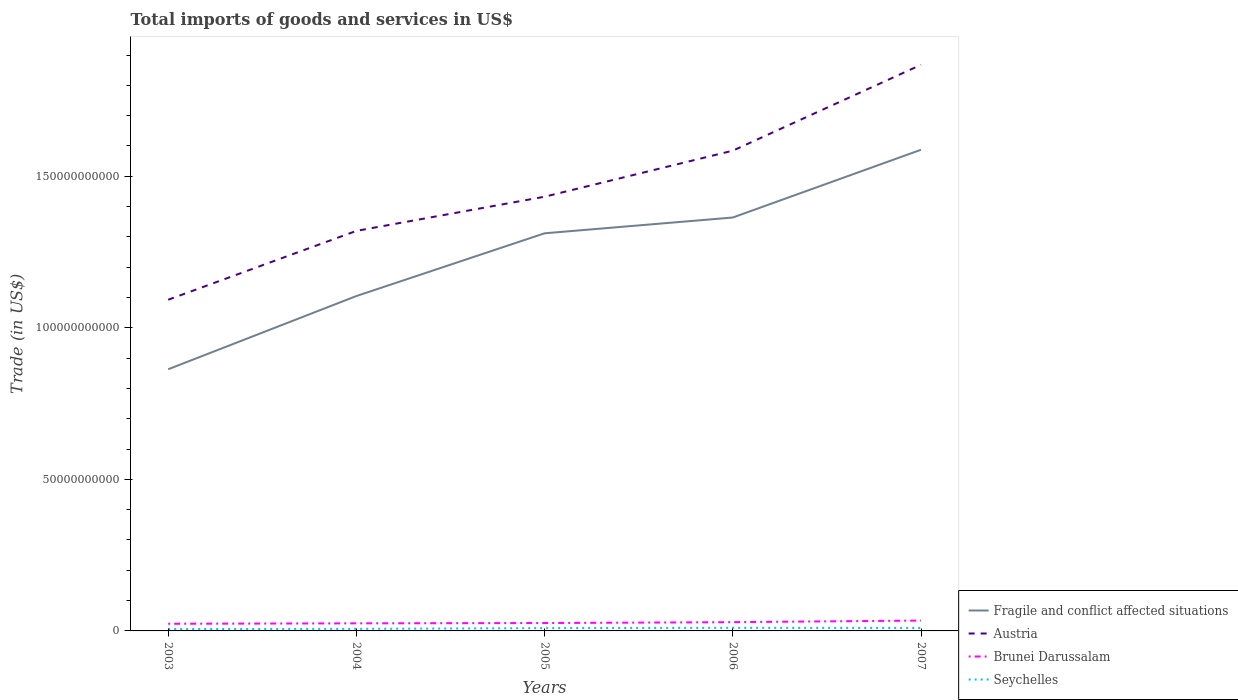How many different coloured lines are there?
Your response must be concise. 4. Does the line corresponding to Brunei Darussalam intersect with the line corresponding to Austria?
Make the answer very short. No. Is the number of lines equal to the number of legend labels?
Offer a very short reply. Yes. Across all years, what is the maximum total imports of goods and services in Brunei Darussalam?
Make the answer very short. 2.36e+09. In which year was the total imports of goods and services in Austria maximum?
Your answer should be very brief. 2003. What is the total total imports of goods and services in Brunei Darussalam in the graph?
Your response must be concise. -9.14e+08. What is the difference between the highest and the second highest total imports of goods and services in Fragile and conflict affected situations?
Offer a very short reply. 7.24e+1. Is the total imports of goods and services in Fragile and conflict affected situations strictly greater than the total imports of goods and services in Brunei Darussalam over the years?
Your answer should be very brief. No. What is the difference between two consecutive major ticks on the Y-axis?
Provide a succinct answer. 5.00e+1. Are the values on the major ticks of Y-axis written in scientific E-notation?
Your response must be concise. No. Does the graph contain grids?
Your answer should be very brief. No. How many legend labels are there?
Offer a terse response. 4. How are the legend labels stacked?
Provide a succinct answer. Vertical. What is the title of the graph?
Offer a very short reply. Total imports of goods and services in US$. Does "Kenya" appear as one of the legend labels in the graph?
Your answer should be very brief. No. What is the label or title of the X-axis?
Your answer should be compact. Years. What is the label or title of the Y-axis?
Your response must be concise. Trade (in US$). What is the Trade (in US$) in Fragile and conflict affected situations in 2003?
Your answer should be very brief. 8.63e+1. What is the Trade (in US$) of Austria in 2003?
Provide a succinct answer. 1.09e+11. What is the Trade (in US$) in Brunei Darussalam in 2003?
Make the answer very short. 2.36e+09. What is the Trade (in US$) in Seychelles in 2003?
Offer a very short reply. 6.11e+08. What is the Trade (in US$) in Fragile and conflict affected situations in 2004?
Your response must be concise. 1.10e+11. What is the Trade (in US$) of Austria in 2004?
Give a very brief answer. 1.32e+11. What is the Trade (in US$) in Brunei Darussalam in 2004?
Keep it short and to the point. 2.50e+09. What is the Trade (in US$) in Seychelles in 2004?
Your answer should be compact. 6.85e+08. What is the Trade (in US$) of Fragile and conflict affected situations in 2005?
Provide a short and direct response. 1.31e+11. What is the Trade (in US$) in Austria in 2005?
Provide a succinct answer. 1.43e+11. What is the Trade (in US$) in Brunei Darussalam in 2005?
Ensure brevity in your answer.  2.60e+09. What is the Trade (in US$) in Seychelles in 2005?
Ensure brevity in your answer.  9.19e+08. What is the Trade (in US$) in Fragile and conflict affected situations in 2006?
Provide a short and direct response. 1.36e+11. What is the Trade (in US$) of Austria in 2006?
Provide a succinct answer. 1.58e+11. What is the Trade (in US$) of Brunei Darussalam in 2006?
Your response must be concise. 2.89e+09. What is the Trade (in US$) of Seychelles in 2006?
Your response must be concise. 1.02e+09. What is the Trade (in US$) of Fragile and conflict affected situations in 2007?
Ensure brevity in your answer.  1.59e+11. What is the Trade (in US$) in Austria in 2007?
Offer a very short reply. 1.87e+11. What is the Trade (in US$) in Brunei Darussalam in 2007?
Provide a succinct answer. 3.42e+09. What is the Trade (in US$) in Seychelles in 2007?
Your answer should be compact. 9.49e+08. Across all years, what is the maximum Trade (in US$) of Fragile and conflict affected situations?
Ensure brevity in your answer.  1.59e+11. Across all years, what is the maximum Trade (in US$) in Austria?
Offer a terse response. 1.87e+11. Across all years, what is the maximum Trade (in US$) in Brunei Darussalam?
Give a very brief answer. 3.42e+09. Across all years, what is the maximum Trade (in US$) in Seychelles?
Provide a succinct answer. 1.02e+09. Across all years, what is the minimum Trade (in US$) in Fragile and conflict affected situations?
Your answer should be very brief. 8.63e+1. Across all years, what is the minimum Trade (in US$) in Austria?
Ensure brevity in your answer.  1.09e+11. Across all years, what is the minimum Trade (in US$) in Brunei Darussalam?
Your answer should be very brief. 2.36e+09. Across all years, what is the minimum Trade (in US$) of Seychelles?
Your answer should be very brief. 6.11e+08. What is the total Trade (in US$) of Fragile and conflict affected situations in the graph?
Provide a succinct answer. 6.23e+11. What is the total Trade (in US$) in Austria in the graph?
Make the answer very short. 7.30e+11. What is the total Trade (in US$) of Brunei Darussalam in the graph?
Your answer should be very brief. 1.38e+1. What is the total Trade (in US$) of Seychelles in the graph?
Your answer should be very brief. 4.19e+09. What is the difference between the Trade (in US$) of Fragile and conflict affected situations in 2003 and that in 2004?
Provide a succinct answer. -2.42e+1. What is the difference between the Trade (in US$) of Austria in 2003 and that in 2004?
Your response must be concise. -2.27e+1. What is the difference between the Trade (in US$) of Brunei Darussalam in 2003 and that in 2004?
Provide a short and direct response. -1.44e+08. What is the difference between the Trade (in US$) in Seychelles in 2003 and that in 2004?
Provide a short and direct response. -7.40e+07. What is the difference between the Trade (in US$) of Fragile and conflict affected situations in 2003 and that in 2005?
Provide a succinct answer. -4.49e+1. What is the difference between the Trade (in US$) in Austria in 2003 and that in 2005?
Ensure brevity in your answer.  -3.40e+1. What is the difference between the Trade (in US$) in Brunei Darussalam in 2003 and that in 2005?
Your response must be concise. -2.42e+08. What is the difference between the Trade (in US$) of Seychelles in 2003 and that in 2005?
Ensure brevity in your answer.  -3.09e+08. What is the difference between the Trade (in US$) of Fragile and conflict affected situations in 2003 and that in 2006?
Your answer should be very brief. -5.01e+1. What is the difference between the Trade (in US$) of Austria in 2003 and that in 2006?
Keep it short and to the point. -4.92e+1. What is the difference between the Trade (in US$) in Brunei Darussalam in 2003 and that in 2006?
Make the answer very short. -5.34e+08. What is the difference between the Trade (in US$) in Seychelles in 2003 and that in 2006?
Your answer should be very brief. -4.11e+08. What is the difference between the Trade (in US$) in Fragile and conflict affected situations in 2003 and that in 2007?
Your response must be concise. -7.24e+1. What is the difference between the Trade (in US$) in Austria in 2003 and that in 2007?
Keep it short and to the point. -7.75e+1. What is the difference between the Trade (in US$) in Brunei Darussalam in 2003 and that in 2007?
Offer a terse response. -1.06e+09. What is the difference between the Trade (in US$) of Seychelles in 2003 and that in 2007?
Give a very brief answer. -3.38e+08. What is the difference between the Trade (in US$) of Fragile and conflict affected situations in 2004 and that in 2005?
Your answer should be very brief. -2.07e+1. What is the difference between the Trade (in US$) in Austria in 2004 and that in 2005?
Ensure brevity in your answer.  -1.13e+1. What is the difference between the Trade (in US$) in Brunei Darussalam in 2004 and that in 2005?
Keep it short and to the point. -9.84e+07. What is the difference between the Trade (in US$) in Seychelles in 2004 and that in 2005?
Provide a succinct answer. -2.35e+08. What is the difference between the Trade (in US$) of Fragile and conflict affected situations in 2004 and that in 2006?
Provide a succinct answer. -2.59e+1. What is the difference between the Trade (in US$) of Austria in 2004 and that in 2006?
Offer a very short reply. -2.65e+1. What is the difference between the Trade (in US$) of Brunei Darussalam in 2004 and that in 2006?
Your answer should be very brief. -3.90e+08. What is the difference between the Trade (in US$) of Seychelles in 2004 and that in 2006?
Provide a succinct answer. -3.37e+08. What is the difference between the Trade (in US$) of Fragile and conflict affected situations in 2004 and that in 2007?
Give a very brief answer. -4.83e+1. What is the difference between the Trade (in US$) in Austria in 2004 and that in 2007?
Keep it short and to the point. -5.48e+1. What is the difference between the Trade (in US$) of Brunei Darussalam in 2004 and that in 2007?
Your answer should be compact. -9.14e+08. What is the difference between the Trade (in US$) of Seychelles in 2004 and that in 2007?
Offer a very short reply. -2.64e+08. What is the difference between the Trade (in US$) of Fragile and conflict affected situations in 2005 and that in 2006?
Keep it short and to the point. -5.21e+09. What is the difference between the Trade (in US$) of Austria in 2005 and that in 2006?
Provide a short and direct response. -1.52e+1. What is the difference between the Trade (in US$) of Brunei Darussalam in 2005 and that in 2006?
Offer a very short reply. -2.91e+08. What is the difference between the Trade (in US$) of Seychelles in 2005 and that in 2006?
Offer a very short reply. -1.03e+08. What is the difference between the Trade (in US$) in Fragile and conflict affected situations in 2005 and that in 2007?
Your answer should be compact. -2.76e+1. What is the difference between the Trade (in US$) of Austria in 2005 and that in 2007?
Ensure brevity in your answer.  -4.35e+1. What is the difference between the Trade (in US$) of Brunei Darussalam in 2005 and that in 2007?
Your answer should be compact. -8.16e+08. What is the difference between the Trade (in US$) of Seychelles in 2005 and that in 2007?
Give a very brief answer. -2.98e+07. What is the difference between the Trade (in US$) of Fragile and conflict affected situations in 2006 and that in 2007?
Offer a terse response. -2.24e+1. What is the difference between the Trade (in US$) in Austria in 2006 and that in 2007?
Offer a terse response. -2.83e+1. What is the difference between the Trade (in US$) in Brunei Darussalam in 2006 and that in 2007?
Make the answer very short. -5.24e+08. What is the difference between the Trade (in US$) of Seychelles in 2006 and that in 2007?
Make the answer very short. 7.29e+07. What is the difference between the Trade (in US$) of Fragile and conflict affected situations in 2003 and the Trade (in US$) of Austria in 2004?
Keep it short and to the point. -4.57e+1. What is the difference between the Trade (in US$) of Fragile and conflict affected situations in 2003 and the Trade (in US$) of Brunei Darussalam in 2004?
Keep it short and to the point. 8.38e+1. What is the difference between the Trade (in US$) of Fragile and conflict affected situations in 2003 and the Trade (in US$) of Seychelles in 2004?
Your answer should be compact. 8.57e+1. What is the difference between the Trade (in US$) of Austria in 2003 and the Trade (in US$) of Brunei Darussalam in 2004?
Provide a succinct answer. 1.07e+11. What is the difference between the Trade (in US$) in Austria in 2003 and the Trade (in US$) in Seychelles in 2004?
Offer a very short reply. 1.09e+11. What is the difference between the Trade (in US$) of Brunei Darussalam in 2003 and the Trade (in US$) of Seychelles in 2004?
Offer a very short reply. 1.67e+09. What is the difference between the Trade (in US$) of Fragile and conflict affected situations in 2003 and the Trade (in US$) of Austria in 2005?
Your answer should be very brief. -5.69e+1. What is the difference between the Trade (in US$) of Fragile and conflict affected situations in 2003 and the Trade (in US$) of Brunei Darussalam in 2005?
Ensure brevity in your answer.  8.37e+1. What is the difference between the Trade (in US$) of Fragile and conflict affected situations in 2003 and the Trade (in US$) of Seychelles in 2005?
Keep it short and to the point. 8.54e+1. What is the difference between the Trade (in US$) in Austria in 2003 and the Trade (in US$) in Brunei Darussalam in 2005?
Offer a very short reply. 1.07e+11. What is the difference between the Trade (in US$) of Austria in 2003 and the Trade (in US$) of Seychelles in 2005?
Provide a short and direct response. 1.08e+11. What is the difference between the Trade (in US$) in Brunei Darussalam in 2003 and the Trade (in US$) in Seychelles in 2005?
Provide a succinct answer. 1.44e+09. What is the difference between the Trade (in US$) of Fragile and conflict affected situations in 2003 and the Trade (in US$) of Austria in 2006?
Your response must be concise. -7.21e+1. What is the difference between the Trade (in US$) of Fragile and conflict affected situations in 2003 and the Trade (in US$) of Brunei Darussalam in 2006?
Your answer should be very brief. 8.34e+1. What is the difference between the Trade (in US$) of Fragile and conflict affected situations in 2003 and the Trade (in US$) of Seychelles in 2006?
Offer a terse response. 8.53e+1. What is the difference between the Trade (in US$) of Austria in 2003 and the Trade (in US$) of Brunei Darussalam in 2006?
Your answer should be compact. 1.06e+11. What is the difference between the Trade (in US$) of Austria in 2003 and the Trade (in US$) of Seychelles in 2006?
Give a very brief answer. 1.08e+11. What is the difference between the Trade (in US$) in Brunei Darussalam in 2003 and the Trade (in US$) in Seychelles in 2006?
Offer a terse response. 1.34e+09. What is the difference between the Trade (in US$) in Fragile and conflict affected situations in 2003 and the Trade (in US$) in Austria in 2007?
Your answer should be very brief. -1.00e+11. What is the difference between the Trade (in US$) in Fragile and conflict affected situations in 2003 and the Trade (in US$) in Brunei Darussalam in 2007?
Your answer should be compact. 8.29e+1. What is the difference between the Trade (in US$) of Fragile and conflict affected situations in 2003 and the Trade (in US$) of Seychelles in 2007?
Your response must be concise. 8.54e+1. What is the difference between the Trade (in US$) of Austria in 2003 and the Trade (in US$) of Brunei Darussalam in 2007?
Ensure brevity in your answer.  1.06e+11. What is the difference between the Trade (in US$) in Austria in 2003 and the Trade (in US$) in Seychelles in 2007?
Your answer should be compact. 1.08e+11. What is the difference between the Trade (in US$) in Brunei Darussalam in 2003 and the Trade (in US$) in Seychelles in 2007?
Your response must be concise. 1.41e+09. What is the difference between the Trade (in US$) in Fragile and conflict affected situations in 2004 and the Trade (in US$) in Austria in 2005?
Keep it short and to the point. -3.28e+1. What is the difference between the Trade (in US$) of Fragile and conflict affected situations in 2004 and the Trade (in US$) of Brunei Darussalam in 2005?
Your response must be concise. 1.08e+11. What is the difference between the Trade (in US$) of Fragile and conflict affected situations in 2004 and the Trade (in US$) of Seychelles in 2005?
Provide a short and direct response. 1.10e+11. What is the difference between the Trade (in US$) in Austria in 2004 and the Trade (in US$) in Brunei Darussalam in 2005?
Give a very brief answer. 1.29e+11. What is the difference between the Trade (in US$) of Austria in 2004 and the Trade (in US$) of Seychelles in 2005?
Offer a terse response. 1.31e+11. What is the difference between the Trade (in US$) of Brunei Darussalam in 2004 and the Trade (in US$) of Seychelles in 2005?
Your answer should be compact. 1.58e+09. What is the difference between the Trade (in US$) of Fragile and conflict affected situations in 2004 and the Trade (in US$) of Austria in 2006?
Give a very brief answer. -4.80e+1. What is the difference between the Trade (in US$) in Fragile and conflict affected situations in 2004 and the Trade (in US$) in Brunei Darussalam in 2006?
Offer a very short reply. 1.08e+11. What is the difference between the Trade (in US$) in Fragile and conflict affected situations in 2004 and the Trade (in US$) in Seychelles in 2006?
Give a very brief answer. 1.09e+11. What is the difference between the Trade (in US$) of Austria in 2004 and the Trade (in US$) of Brunei Darussalam in 2006?
Your answer should be very brief. 1.29e+11. What is the difference between the Trade (in US$) in Austria in 2004 and the Trade (in US$) in Seychelles in 2006?
Your answer should be compact. 1.31e+11. What is the difference between the Trade (in US$) in Brunei Darussalam in 2004 and the Trade (in US$) in Seychelles in 2006?
Your response must be concise. 1.48e+09. What is the difference between the Trade (in US$) in Fragile and conflict affected situations in 2004 and the Trade (in US$) in Austria in 2007?
Offer a very short reply. -7.63e+1. What is the difference between the Trade (in US$) of Fragile and conflict affected situations in 2004 and the Trade (in US$) of Brunei Darussalam in 2007?
Give a very brief answer. 1.07e+11. What is the difference between the Trade (in US$) of Fragile and conflict affected situations in 2004 and the Trade (in US$) of Seychelles in 2007?
Offer a terse response. 1.10e+11. What is the difference between the Trade (in US$) of Austria in 2004 and the Trade (in US$) of Brunei Darussalam in 2007?
Your response must be concise. 1.29e+11. What is the difference between the Trade (in US$) in Austria in 2004 and the Trade (in US$) in Seychelles in 2007?
Provide a succinct answer. 1.31e+11. What is the difference between the Trade (in US$) in Brunei Darussalam in 2004 and the Trade (in US$) in Seychelles in 2007?
Your response must be concise. 1.55e+09. What is the difference between the Trade (in US$) of Fragile and conflict affected situations in 2005 and the Trade (in US$) of Austria in 2006?
Keep it short and to the point. -2.73e+1. What is the difference between the Trade (in US$) of Fragile and conflict affected situations in 2005 and the Trade (in US$) of Brunei Darussalam in 2006?
Offer a terse response. 1.28e+11. What is the difference between the Trade (in US$) in Fragile and conflict affected situations in 2005 and the Trade (in US$) in Seychelles in 2006?
Provide a succinct answer. 1.30e+11. What is the difference between the Trade (in US$) in Austria in 2005 and the Trade (in US$) in Brunei Darussalam in 2006?
Your response must be concise. 1.40e+11. What is the difference between the Trade (in US$) of Austria in 2005 and the Trade (in US$) of Seychelles in 2006?
Your answer should be very brief. 1.42e+11. What is the difference between the Trade (in US$) of Brunei Darussalam in 2005 and the Trade (in US$) of Seychelles in 2006?
Your answer should be very brief. 1.58e+09. What is the difference between the Trade (in US$) in Fragile and conflict affected situations in 2005 and the Trade (in US$) in Austria in 2007?
Ensure brevity in your answer.  -5.56e+1. What is the difference between the Trade (in US$) of Fragile and conflict affected situations in 2005 and the Trade (in US$) of Brunei Darussalam in 2007?
Your answer should be compact. 1.28e+11. What is the difference between the Trade (in US$) of Fragile and conflict affected situations in 2005 and the Trade (in US$) of Seychelles in 2007?
Your answer should be compact. 1.30e+11. What is the difference between the Trade (in US$) of Austria in 2005 and the Trade (in US$) of Brunei Darussalam in 2007?
Provide a succinct answer. 1.40e+11. What is the difference between the Trade (in US$) in Austria in 2005 and the Trade (in US$) in Seychelles in 2007?
Your response must be concise. 1.42e+11. What is the difference between the Trade (in US$) in Brunei Darussalam in 2005 and the Trade (in US$) in Seychelles in 2007?
Offer a very short reply. 1.65e+09. What is the difference between the Trade (in US$) in Fragile and conflict affected situations in 2006 and the Trade (in US$) in Austria in 2007?
Your answer should be compact. -5.04e+1. What is the difference between the Trade (in US$) of Fragile and conflict affected situations in 2006 and the Trade (in US$) of Brunei Darussalam in 2007?
Offer a very short reply. 1.33e+11. What is the difference between the Trade (in US$) in Fragile and conflict affected situations in 2006 and the Trade (in US$) in Seychelles in 2007?
Make the answer very short. 1.35e+11. What is the difference between the Trade (in US$) in Austria in 2006 and the Trade (in US$) in Brunei Darussalam in 2007?
Keep it short and to the point. 1.55e+11. What is the difference between the Trade (in US$) of Austria in 2006 and the Trade (in US$) of Seychelles in 2007?
Provide a succinct answer. 1.58e+11. What is the difference between the Trade (in US$) of Brunei Darussalam in 2006 and the Trade (in US$) of Seychelles in 2007?
Offer a very short reply. 1.94e+09. What is the average Trade (in US$) in Fragile and conflict affected situations per year?
Make the answer very short. 1.25e+11. What is the average Trade (in US$) of Austria per year?
Offer a terse response. 1.46e+11. What is the average Trade (in US$) in Brunei Darussalam per year?
Make the answer very short. 2.75e+09. What is the average Trade (in US$) in Seychelles per year?
Make the answer very short. 8.37e+08. In the year 2003, what is the difference between the Trade (in US$) of Fragile and conflict affected situations and Trade (in US$) of Austria?
Your response must be concise. -2.29e+1. In the year 2003, what is the difference between the Trade (in US$) of Fragile and conflict affected situations and Trade (in US$) of Brunei Darussalam?
Your answer should be compact. 8.40e+1. In the year 2003, what is the difference between the Trade (in US$) in Fragile and conflict affected situations and Trade (in US$) in Seychelles?
Ensure brevity in your answer.  8.57e+1. In the year 2003, what is the difference between the Trade (in US$) in Austria and Trade (in US$) in Brunei Darussalam?
Your answer should be compact. 1.07e+11. In the year 2003, what is the difference between the Trade (in US$) in Austria and Trade (in US$) in Seychelles?
Your response must be concise. 1.09e+11. In the year 2003, what is the difference between the Trade (in US$) of Brunei Darussalam and Trade (in US$) of Seychelles?
Provide a short and direct response. 1.75e+09. In the year 2004, what is the difference between the Trade (in US$) in Fragile and conflict affected situations and Trade (in US$) in Austria?
Offer a terse response. -2.15e+1. In the year 2004, what is the difference between the Trade (in US$) of Fragile and conflict affected situations and Trade (in US$) of Brunei Darussalam?
Offer a terse response. 1.08e+11. In the year 2004, what is the difference between the Trade (in US$) in Fragile and conflict affected situations and Trade (in US$) in Seychelles?
Provide a short and direct response. 1.10e+11. In the year 2004, what is the difference between the Trade (in US$) of Austria and Trade (in US$) of Brunei Darussalam?
Provide a succinct answer. 1.29e+11. In the year 2004, what is the difference between the Trade (in US$) in Austria and Trade (in US$) in Seychelles?
Your response must be concise. 1.31e+11. In the year 2004, what is the difference between the Trade (in US$) in Brunei Darussalam and Trade (in US$) in Seychelles?
Ensure brevity in your answer.  1.82e+09. In the year 2005, what is the difference between the Trade (in US$) in Fragile and conflict affected situations and Trade (in US$) in Austria?
Make the answer very short. -1.21e+1. In the year 2005, what is the difference between the Trade (in US$) of Fragile and conflict affected situations and Trade (in US$) of Brunei Darussalam?
Keep it short and to the point. 1.29e+11. In the year 2005, what is the difference between the Trade (in US$) of Fragile and conflict affected situations and Trade (in US$) of Seychelles?
Offer a terse response. 1.30e+11. In the year 2005, what is the difference between the Trade (in US$) of Austria and Trade (in US$) of Brunei Darussalam?
Your answer should be compact. 1.41e+11. In the year 2005, what is the difference between the Trade (in US$) in Austria and Trade (in US$) in Seychelles?
Keep it short and to the point. 1.42e+11. In the year 2005, what is the difference between the Trade (in US$) in Brunei Darussalam and Trade (in US$) in Seychelles?
Give a very brief answer. 1.68e+09. In the year 2006, what is the difference between the Trade (in US$) in Fragile and conflict affected situations and Trade (in US$) in Austria?
Offer a very short reply. -2.21e+1. In the year 2006, what is the difference between the Trade (in US$) of Fragile and conflict affected situations and Trade (in US$) of Brunei Darussalam?
Provide a succinct answer. 1.34e+11. In the year 2006, what is the difference between the Trade (in US$) in Fragile and conflict affected situations and Trade (in US$) in Seychelles?
Ensure brevity in your answer.  1.35e+11. In the year 2006, what is the difference between the Trade (in US$) of Austria and Trade (in US$) of Brunei Darussalam?
Your answer should be compact. 1.56e+11. In the year 2006, what is the difference between the Trade (in US$) in Austria and Trade (in US$) in Seychelles?
Keep it short and to the point. 1.57e+11. In the year 2006, what is the difference between the Trade (in US$) in Brunei Darussalam and Trade (in US$) in Seychelles?
Your response must be concise. 1.87e+09. In the year 2007, what is the difference between the Trade (in US$) in Fragile and conflict affected situations and Trade (in US$) in Austria?
Provide a succinct answer. -2.80e+1. In the year 2007, what is the difference between the Trade (in US$) in Fragile and conflict affected situations and Trade (in US$) in Brunei Darussalam?
Provide a short and direct response. 1.55e+11. In the year 2007, what is the difference between the Trade (in US$) of Fragile and conflict affected situations and Trade (in US$) of Seychelles?
Make the answer very short. 1.58e+11. In the year 2007, what is the difference between the Trade (in US$) in Austria and Trade (in US$) in Brunei Darussalam?
Offer a terse response. 1.83e+11. In the year 2007, what is the difference between the Trade (in US$) of Austria and Trade (in US$) of Seychelles?
Offer a very short reply. 1.86e+11. In the year 2007, what is the difference between the Trade (in US$) of Brunei Darussalam and Trade (in US$) of Seychelles?
Your answer should be very brief. 2.47e+09. What is the ratio of the Trade (in US$) in Fragile and conflict affected situations in 2003 to that in 2004?
Provide a succinct answer. 0.78. What is the ratio of the Trade (in US$) of Austria in 2003 to that in 2004?
Offer a very short reply. 0.83. What is the ratio of the Trade (in US$) in Brunei Darussalam in 2003 to that in 2004?
Offer a terse response. 0.94. What is the ratio of the Trade (in US$) in Seychelles in 2003 to that in 2004?
Make the answer very short. 0.89. What is the ratio of the Trade (in US$) in Fragile and conflict affected situations in 2003 to that in 2005?
Your response must be concise. 0.66. What is the ratio of the Trade (in US$) of Austria in 2003 to that in 2005?
Provide a short and direct response. 0.76. What is the ratio of the Trade (in US$) of Brunei Darussalam in 2003 to that in 2005?
Provide a short and direct response. 0.91. What is the ratio of the Trade (in US$) of Seychelles in 2003 to that in 2005?
Provide a succinct answer. 0.66. What is the ratio of the Trade (in US$) of Fragile and conflict affected situations in 2003 to that in 2006?
Your answer should be compact. 0.63. What is the ratio of the Trade (in US$) of Austria in 2003 to that in 2006?
Give a very brief answer. 0.69. What is the ratio of the Trade (in US$) in Brunei Darussalam in 2003 to that in 2006?
Offer a terse response. 0.82. What is the ratio of the Trade (in US$) of Seychelles in 2003 to that in 2006?
Provide a succinct answer. 0.6. What is the ratio of the Trade (in US$) of Fragile and conflict affected situations in 2003 to that in 2007?
Give a very brief answer. 0.54. What is the ratio of the Trade (in US$) in Austria in 2003 to that in 2007?
Offer a very short reply. 0.58. What is the ratio of the Trade (in US$) in Brunei Darussalam in 2003 to that in 2007?
Your answer should be compact. 0.69. What is the ratio of the Trade (in US$) of Seychelles in 2003 to that in 2007?
Provide a short and direct response. 0.64. What is the ratio of the Trade (in US$) in Fragile and conflict affected situations in 2004 to that in 2005?
Your response must be concise. 0.84. What is the ratio of the Trade (in US$) in Austria in 2004 to that in 2005?
Provide a short and direct response. 0.92. What is the ratio of the Trade (in US$) of Brunei Darussalam in 2004 to that in 2005?
Offer a very short reply. 0.96. What is the ratio of the Trade (in US$) in Seychelles in 2004 to that in 2005?
Offer a terse response. 0.74. What is the ratio of the Trade (in US$) of Fragile and conflict affected situations in 2004 to that in 2006?
Offer a very short reply. 0.81. What is the ratio of the Trade (in US$) of Austria in 2004 to that in 2006?
Keep it short and to the point. 0.83. What is the ratio of the Trade (in US$) in Brunei Darussalam in 2004 to that in 2006?
Offer a terse response. 0.87. What is the ratio of the Trade (in US$) of Seychelles in 2004 to that in 2006?
Your response must be concise. 0.67. What is the ratio of the Trade (in US$) in Fragile and conflict affected situations in 2004 to that in 2007?
Your response must be concise. 0.7. What is the ratio of the Trade (in US$) in Austria in 2004 to that in 2007?
Make the answer very short. 0.71. What is the ratio of the Trade (in US$) of Brunei Darussalam in 2004 to that in 2007?
Give a very brief answer. 0.73. What is the ratio of the Trade (in US$) in Seychelles in 2004 to that in 2007?
Offer a terse response. 0.72. What is the ratio of the Trade (in US$) of Fragile and conflict affected situations in 2005 to that in 2006?
Your answer should be compact. 0.96. What is the ratio of the Trade (in US$) in Austria in 2005 to that in 2006?
Provide a short and direct response. 0.9. What is the ratio of the Trade (in US$) of Brunei Darussalam in 2005 to that in 2006?
Offer a terse response. 0.9. What is the ratio of the Trade (in US$) of Seychelles in 2005 to that in 2006?
Your response must be concise. 0.9. What is the ratio of the Trade (in US$) of Fragile and conflict affected situations in 2005 to that in 2007?
Make the answer very short. 0.83. What is the ratio of the Trade (in US$) of Austria in 2005 to that in 2007?
Keep it short and to the point. 0.77. What is the ratio of the Trade (in US$) of Brunei Darussalam in 2005 to that in 2007?
Give a very brief answer. 0.76. What is the ratio of the Trade (in US$) in Seychelles in 2005 to that in 2007?
Your response must be concise. 0.97. What is the ratio of the Trade (in US$) of Fragile and conflict affected situations in 2006 to that in 2007?
Keep it short and to the point. 0.86. What is the ratio of the Trade (in US$) of Austria in 2006 to that in 2007?
Ensure brevity in your answer.  0.85. What is the ratio of the Trade (in US$) of Brunei Darussalam in 2006 to that in 2007?
Your answer should be compact. 0.85. What is the ratio of the Trade (in US$) in Seychelles in 2006 to that in 2007?
Keep it short and to the point. 1.08. What is the difference between the highest and the second highest Trade (in US$) in Fragile and conflict affected situations?
Keep it short and to the point. 2.24e+1. What is the difference between the highest and the second highest Trade (in US$) of Austria?
Ensure brevity in your answer.  2.83e+1. What is the difference between the highest and the second highest Trade (in US$) of Brunei Darussalam?
Provide a short and direct response. 5.24e+08. What is the difference between the highest and the second highest Trade (in US$) in Seychelles?
Your answer should be compact. 7.29e+07. What is the difference between the highest and the lowest Trade (in US$) in Fragile and conflict affected situations?
Your answer should be very brief. 7.24e+1. What is the difference between the highest and the lowest Trade (in US$) in Austria?
Provide a succinct answer. 7.75e+1. What is the difference between the highest and the lowest Trade (in US$) of Brunei Darussalam?
Offer a terse response. 1.06e+09. What is the difference between the highest and the lowest Trade (in US$) of Seychelles?
Offer a terse response. 4.11e+08. 